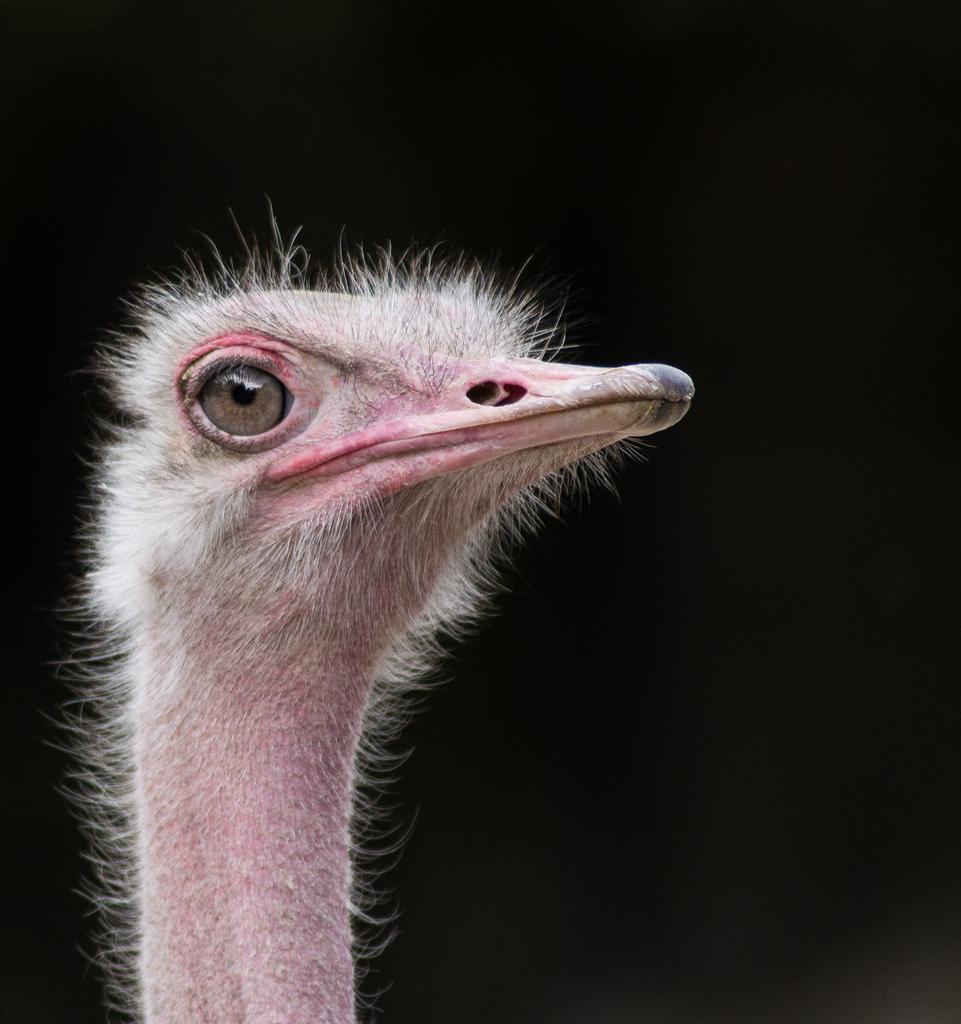Could you give a brief overview of what you see in this image? In the center of the image there is an ostrich. 